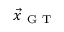Convert formula to latex. <formula><loc_0><loc_0><loc_500><loc_500>\vec { x } _ { G T }</formula> 